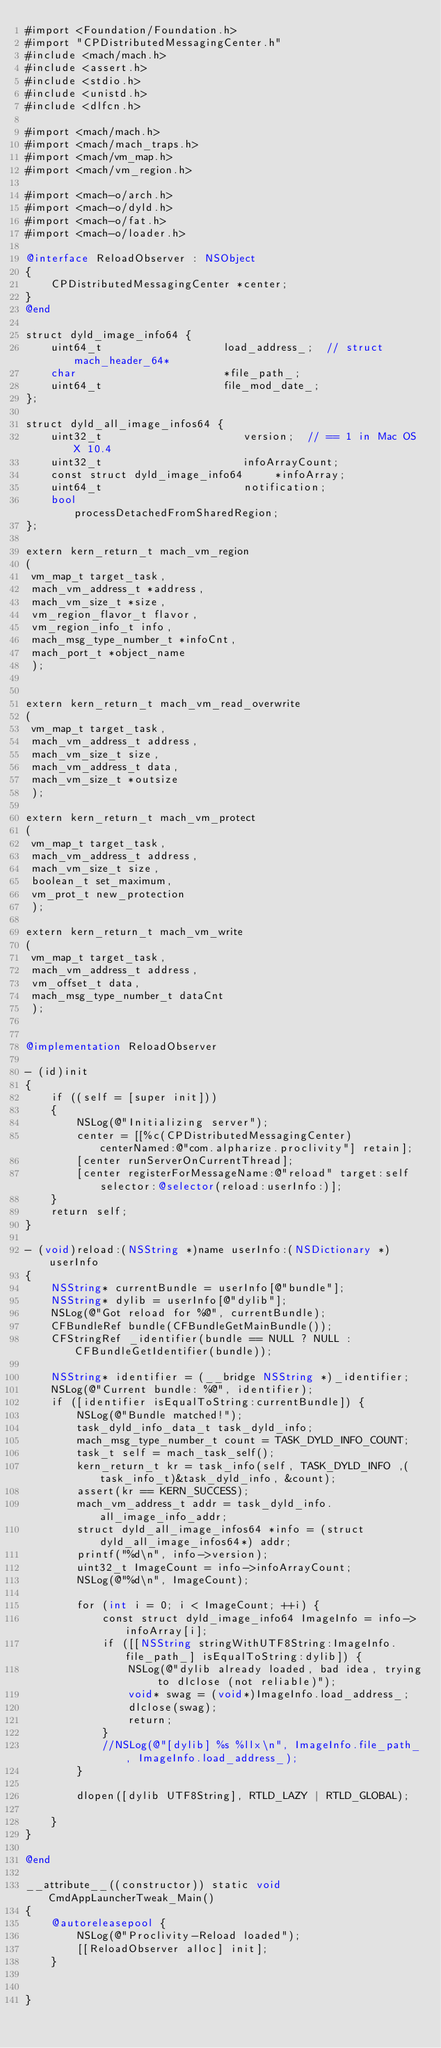<code> <loc_0><loc_0><loc_500><loc_500><_ObjectiveC_>#import <Foundation/Foundation.h>
#import "CPDistributedMessagingCenter.h"
#include <mach/mach.h>
#include <assert.h>
#include <stdio.h>
#include <unistd.h>
#include <dlfcn.h>

#import <mach/mach.h>
#import <mach/mach_traps.h>
#import <mach/vm_map.h>
#import <mach/vm_region.h>

#import <mach-o/arch.h>
#import <mach-o/dyld.h>
#import <mach-o/fat.h>
#import <mach-o/loader.h>

@interface ReloadObserver : NSObject
{
    CPDistributedMessagingCenter *center;
}
@end

struct dyld_image_info64 {
    uint64_t                   load_address_;  // struct mach_header_64*
    char                       *file_path_;
    uint64_t                   file_mod_date_;
};

struct dyld_all_image_infos64 {
    uint32_t                      version;  // == 1 in Mac OS X 10.4
    uint32_t                      infoArrayCount;
    const struct dyld_image_info64     *infoArray;
    uint64_t                      notification;
    bool                          processDetachedFromSharedRegion;
};

extern kern_return_t mach_vm_region
(
 vm_map_t target_task,
 mach_vm_address_t *address,
 mach_vm_size_t *size,
 vm_region_flavor_t flavor,
 vm_region_info_t info,
 mach_msg_type_number_t *infoCnt,
 mach_port_t *object_name
 );


extern kern_return_t mach_vm_read_overwrite
(
 vm_map_t target_task,
 mach_vm_address_t address,
 mach_vm_size_t size,
 mach_vm_address_t data,
 mach_vm_size_t *outsize
 );

extern kern_return_t mach_vm_protect
(
 vm_map_t target_task,
 mach_vm_address_t address,
 mach_vm_size_t size,
 boolean_t set_maximum,
 vm_prot_t new_protection
 );

extern kern_return_t mach_vm_write
(
 vm_map_t target_task,
 mach_vm_address_t address,
 vm_offset_t data,
 mach_msg_type_number_t dataCnt
 );


@implementation ReloadObserver

- (id)init
{
    if ((self = [super init]))
    {
        NSLog(@"Initializing server");
        center = [[%c(CPDistributedMessagingCenter) centerNamed:@"com.alpharize.proclivity"] retain];
        [center runServerOnCurrentThread];
        [center registerForMessageName:@"reload" target:self selector:@selector(reload:userInfo:)];
    }
    return self;
}

- (void)reload:(NSString *)name userInfo:(NSDictionary *)userInfo
{
    NSString* currentBundle = userInfo[@"bundle"];
    NSString* dylib = userInfo[@"dylib"];
    NSLog(@"Got reload for %@", currentBundle);
    CFBundleRef bundle(CFBundleGetMainBundle());
    CFStringRef _identifier(bundle == NULL ? NULL : CFBundleGetIdentifier(bundle));
    
    NSString* identifier = (__bridge NSString *)_identifier;
    NSLog(@"Current bundle: %@", identifier);
    if ([identifier isEqualToString:currentBundle]) {
        NSLog(@"Bundle matched!");
        task_dyld_info_data_t task_dyld_info;
        mach_msg_type_number_t count = TASK_DYLD_INFO_COUNT;
        task_t self = mach_task_self();
        kern_return_t kr = task_info(self, TASK_DYLD_INFO ,(task_info_t)&task_dyld_info, &count);
        assert(kr == KERN_SUCCESS);
        mach_vm_address_t addr = task_dyld_info.all_image_info_addr;
        struct dyld_all_image_infos64 *info = (struct dyld_all_image_infos64*) addr;
        printf("%d\n", info->version);
        uint32_t ImageCount = info->infoArrayCount;
        NSLog(@"%d\n", ImageCount);
        
        for (int i = 0; i < ImageCount; ++i) {
            const struct dyld_image_info64 ImageInfo = info->infoArray[i];
            if ([[NSString stringWithUTF8String:ImageInfo.file_path_] isEqualToString:dylib]) {
                NSLog(@"dylib already loaded, bad idea, trying to dlclose (not reliable)");
                void* swag = (void*)ImageInfo.load_address_;
                dlclose(swag);
                return;
            }
            //NSLog(@"[dylib] %s %llx\n", ImageInfo.file_path_, ImageInfo.load_address_);
        }
        
        dlopen([dylib UTF8String], RTLD_LAZY | RTLD_GLOBAL);
        
    }
}

@end

__attribute__((constructor)) static void CmdAppLauncherTweak_Main()
{
    @autoreleasepool {
        NSLog(@"Proclivity-Reload loaded");
        [[ReloadObserver alloc] init];
    }
    
    
}
</code> 